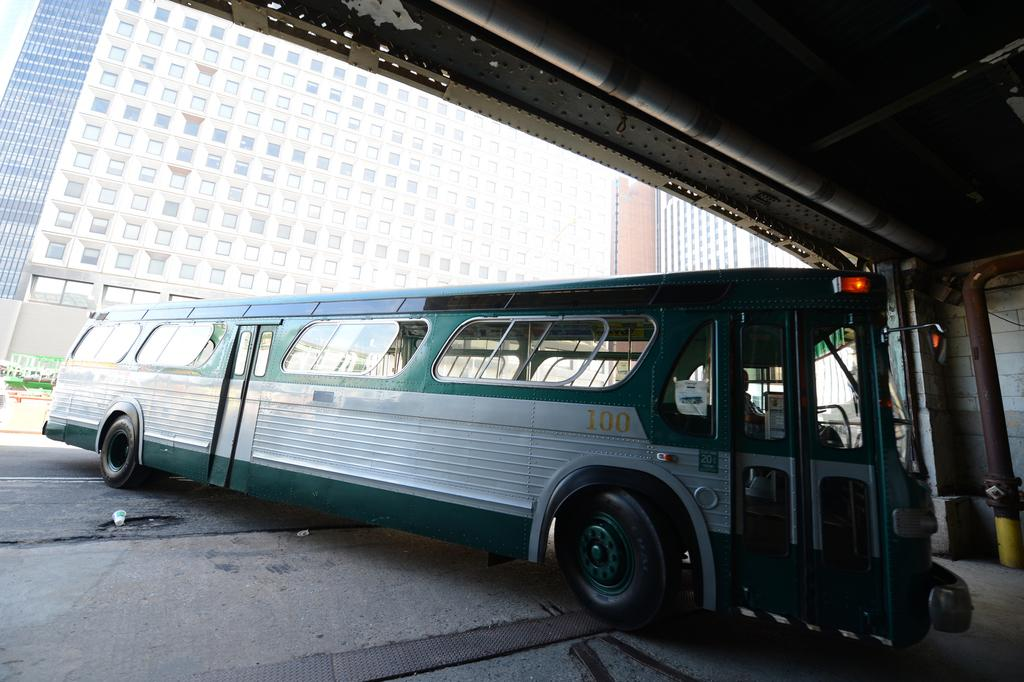What type of vehicle is in the picture? There is a green color bus in the picture. What can be seen in the background of the picture? There is a large building with a number of windows in the background of the picture. What type of baseball is being played in the picture? There is no baseball or any indication of a game being played in the picture; it features a green color bus and a large building in the background. 